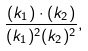<formula> <loc_0><loc_0><loc_500><loc_500>\frac { ( k _ { 1 } ) \cdot ( k _ { 2 } ) } { ( k _ { 1 } ) ^ { 2 } ( k _ { 2 } ) ^ { 2 } } ,</formula> 